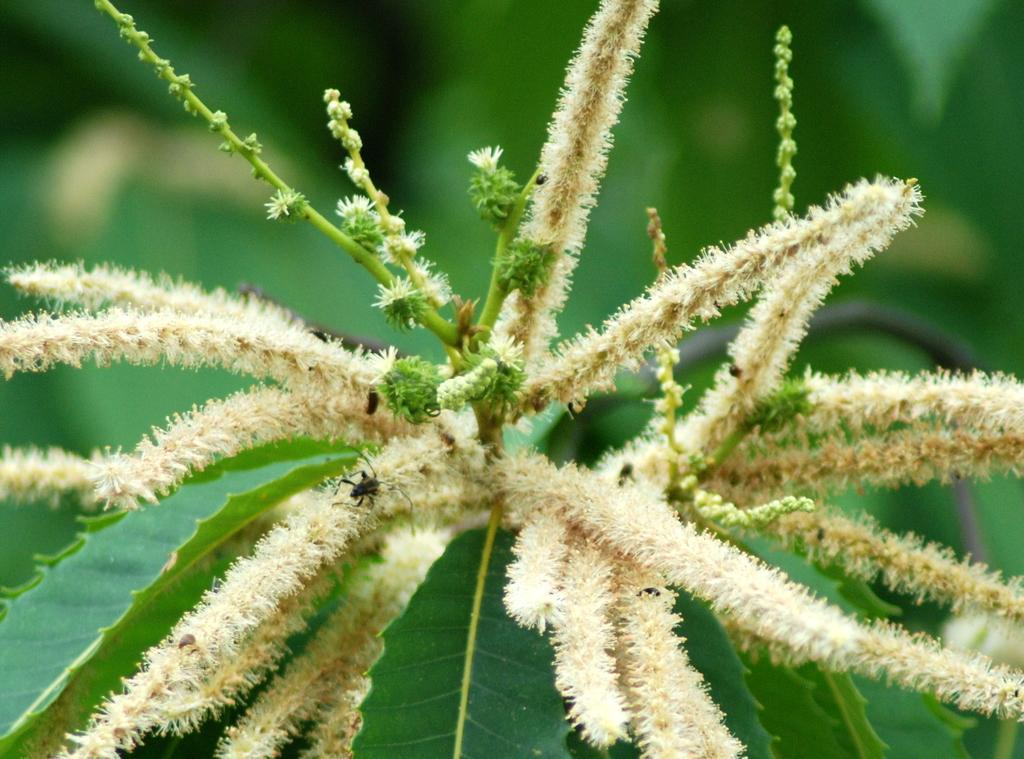What is the main subject of the image? There is a flower in the center of the image. What else can be seen in the image besides the flower? There are leaves in the image. What type of berry is growing on the side of the flower in the image? There is no berry present in the image; it only features a flower and leaves. 